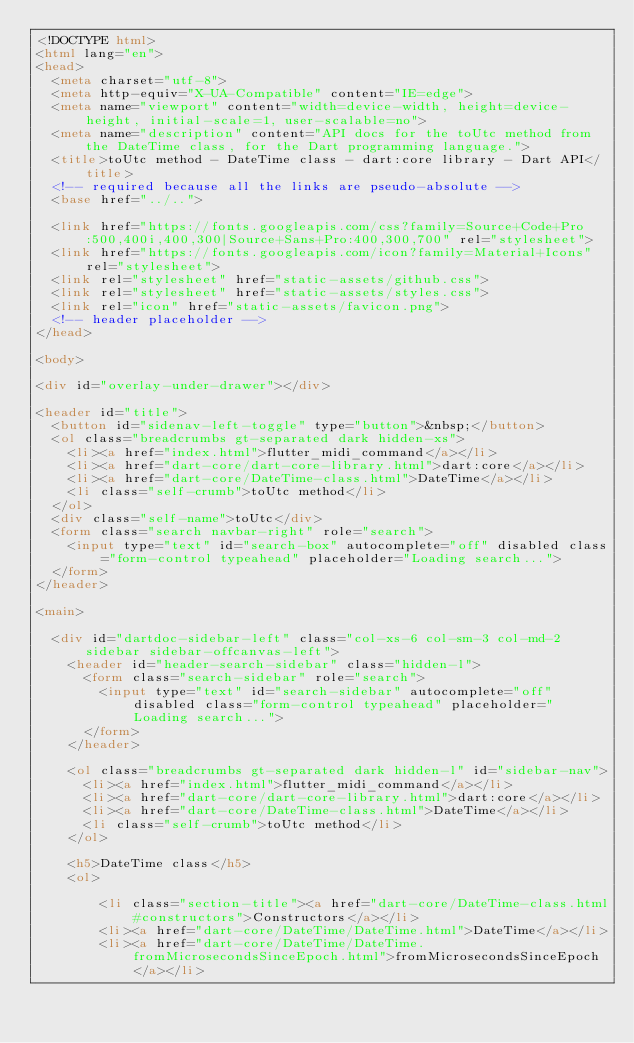Convert code to text. <code><loc_0><loc_0><loc_500><loc_500><_HTML_><!DOCTYPE html>
<html lang="en">
<head>
  <meta charset="utf-8">
  <meta http-equiv="X-UA-Compatible" content="IE=edge">
  <meta name="viewport" content="width=device-width, height=device-height, initial-scale=1, user-scalable=no">
  <meta name="description" content="API docs for the toUtc method from the DateTime class, for the Dart programming language.">
  <title>toUtc method - DateTime class - dart:core library - Dart API</title>
  <!-- required because all the links are pseudo-absolute -->
  <base href="../..">

  <link href="https://fonts.googleapis.com/css?family=Source+Code+Pro:500,400i,400,300|Source+Sans+Pro:400,300,700" rel="stylesheet">
  <link href="https://fonts.googleapis.com/icon?family=Material+Icons" rel="stylesheet">
  <link rel="stylesheet" href="static-assets/github.css">
  <link rel="stylesheet" href="static-assets/styles.css">
  <link rel="icon" href="static-assets/favicon.png">
  <!-- header placeholder -->
</head>

<body>

<div id="overlay-under-drawer"></div>

<header id="title">
  <button id="sidenav-left-toggle" type="button">&nbsp;</button>
  <ol class="breadcrumbs gt-separated dark hidden-xs">
    <li><a href="index.html">flutter_midi_command</a></li>
    <li><a href="dart-core/dart-core-library.html">dart:core</a></li>
    <li><a href="dart-core/DateTime-class.html">DateTime</a></li>
    <li class="self-crumb">toUtc method</li>
  </ol>
  <div class="self-name">toUtc</div>
  <form class="search navbar-right" role="search">
    <input type="text" id="search-box" autocomplete="off" disabled class="form-control typeahead" placeholder="Loading search...">
  </form>
</header>

<main>

  <div id="dartdoc-sidebar-left" class="col-xs-6 col-sm-3 col-md-2 sidebar sidebar-offcanvas-left">
    <header id="header-search-sidebar" class="hidden-l">
      <form class="search-sidebar" role="search">
        <input type="text" id="search-sidebar" autocomplete="off" disabled class="form-control typeahead" placeholder="Loading search...">
      </form>
    </header>
    
    <ol class="breadcrumbs gt-separated dark hidden-l" id="sidebar-nav">
      <li><a href="index.html">flutter_midi_command</a></li>
      <li><a href="dart-core/dart-core-library.html">dart:core</a></li>
      <li><a href="dart-core/DateTime-class.html">DateTime</a></li>
      <li class="self-crumb">toUtc method</li>
    </ol>
    
    <h5>DateTime class</h5>
    <ol>
    
        <li class="section-title"><a href="dart-core/DateTime-class.html#constructors">Constructors</a></li>
        <li><a href="dart-core/DateTime/DateTime.html">DateTime</a></li>
        <li><a href="dart-core/DateTime/DateTime.fromMicrosecondsSinceEpoch.html">fromMicrosecondsSinceEpoch</a></li></code> 